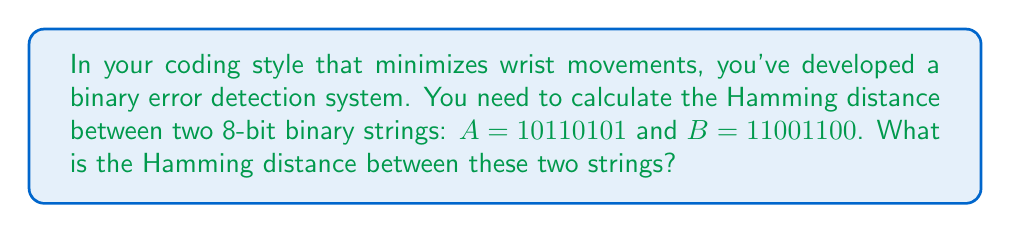Provide a solution to this math problem. To calculate the Hamming distance between two binary strings, we need to count the number of positions at which the corresponding bits are different. Let's go through this step-by-step:

1. First, let's align the two binary strings:

   $A = 10110101$
   $B = 11001100$

2. Now, we'll compare each bit position:

   Position 1: $1 \neq 1$ (same)
   Position 2: $0 \neq 1$ (different)
   Position 3: $1 = 1$ (same)
   Position 4: $1 \neq 0$ (different)
   Position 5: $0 = 0$ (same)
   Position 6: $1 \neq 1$ (same)
   Position 7: $0 \neq 0$ (same)
   Position 8: $1 \neq 0$ (different)

3. Count the number of positions where the bits are different:

   There are differences at positions 2, 4, and 8.

4. The Hamming distance is the total count of these differences:

   $\text{Hamming distance} = 3$

This approach is particularly suitable for a coding style that minimizes wrist movements, as it involves a simple left-to-right comparison and a straightforward count, which can be efficiently implemented in code.
Answer: The Hamming distance between $A = 10110101$ and $B = 11001100$ is $3$. 